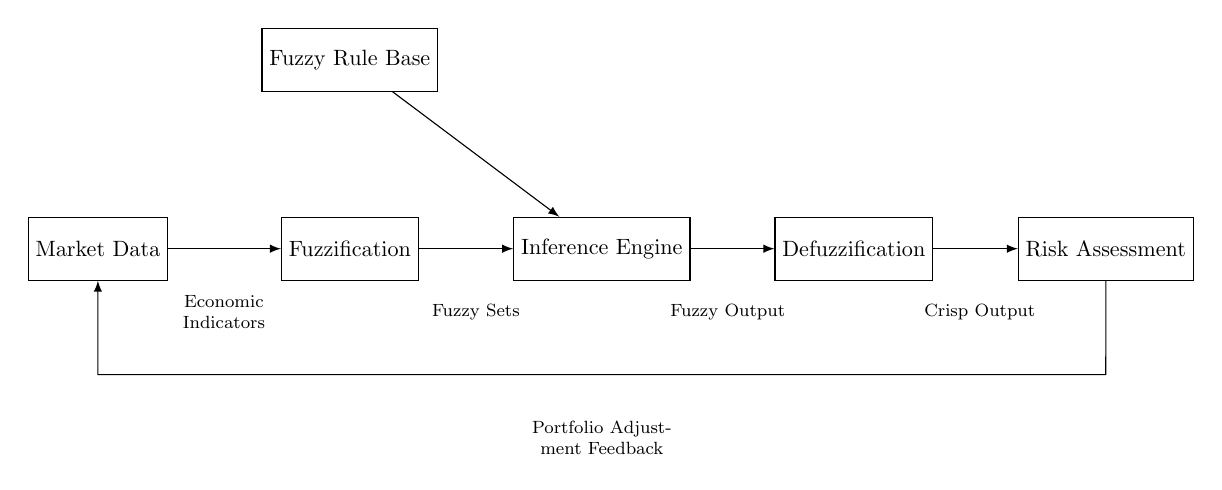What is the input to the system? The input to the system is Market Data, which represents the initial data used for risk assessment.
Answer: Market Data What comes after the Fuzzification block? Following the Fuzzification block, the data is processed by the Inference Engine, which applies fuzzy rules to the fuzzified data.
Answer: Inference Engine What are the components involved in this control system? The components of this control system include Market Data, Fuzzification, Fuzzy Rule Base, Inference Engine, Defuzzification, and Risk Assessment.
Answer: Market Data, Fuzzification, Fuzzy Rule Base, Inference Engine, Defuzzification, Risk Assessment How does the output affect the input in this system? The output leads to feedback, which is routed back to the input (Market Data), establishing a continuous loop for improvement in the risk assessment process.
Answer: Feedback loop What does the Defuzzification block produce? The Defuzzification block produces Crisp Output, which is the final risk assessment after processing the fuzzy outputs.
Answer: Crisp Output Which component uses the Fuzzy Rule Base? The Inference Engine utilizes the Fuzzy Rule Base to process the fuzzified data and derive outcomes based on the fuzzy logic rules.
Answer: Inference Engine What indicates the return path in the circuit? The return path in the circuit is indicated by the feedback loop connecting the output back to the input (Market Data).
Answer: Feedback loop 